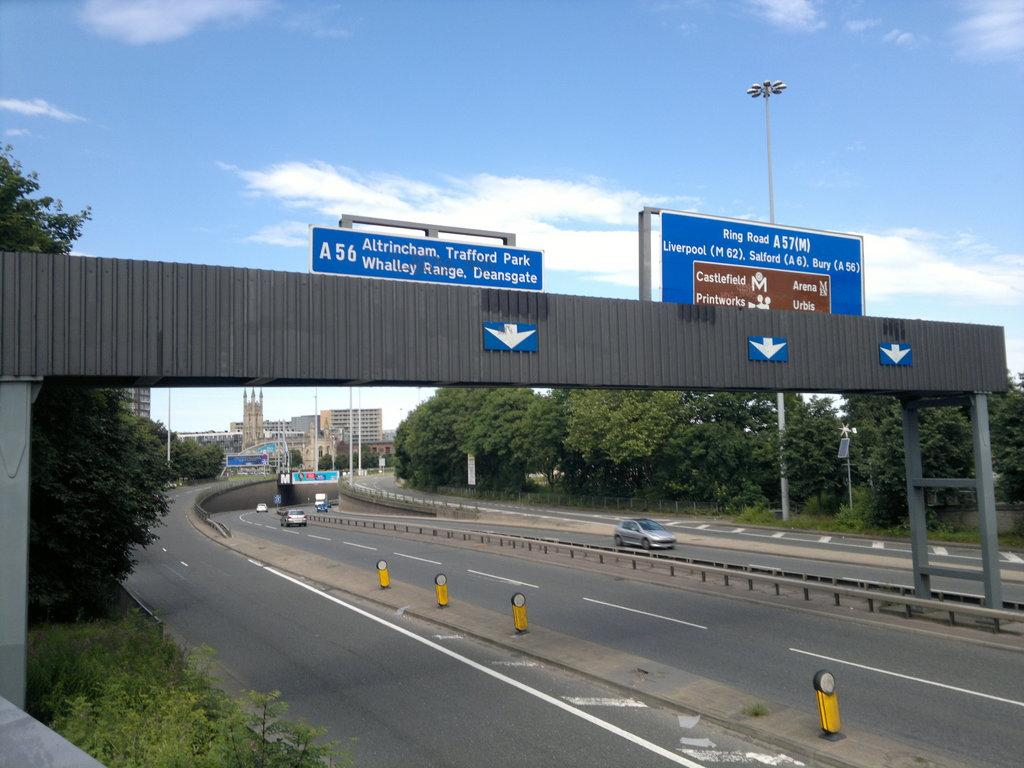<image>
Relay a brief, clear account of the picture shown. A highway with signs for exits A56 and A57. 